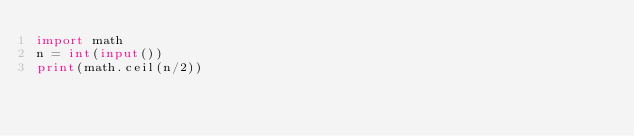<code> <loc_0><loc_0><loc_500><loc_500><_Python_>import math
n = int(input())
print(math.ceil(n/2))
</code> 